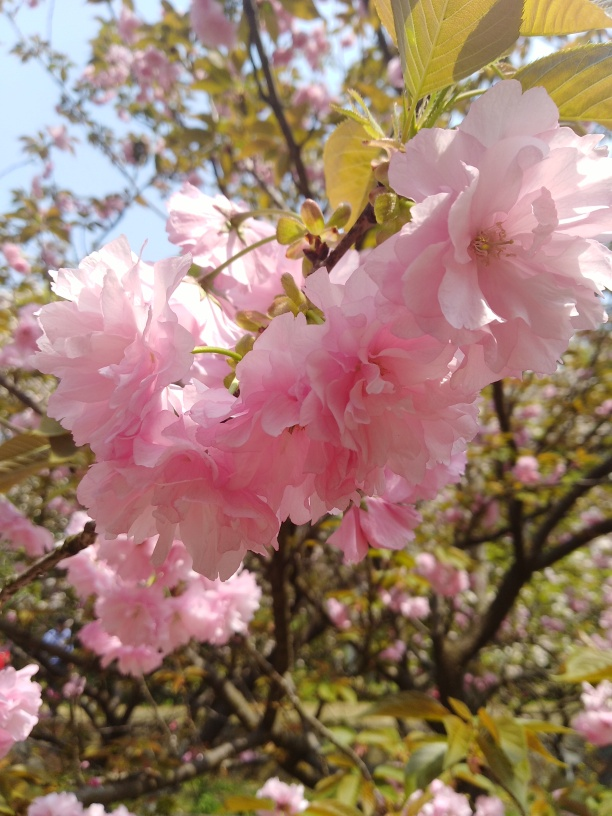What kind of tree is shown in this image? The tree in the image is a cherry blossom, known scientifically as Prunus serrulata. These trees are famous for their beautiful and transient flowering season, an emblem of spring in many cultures. 